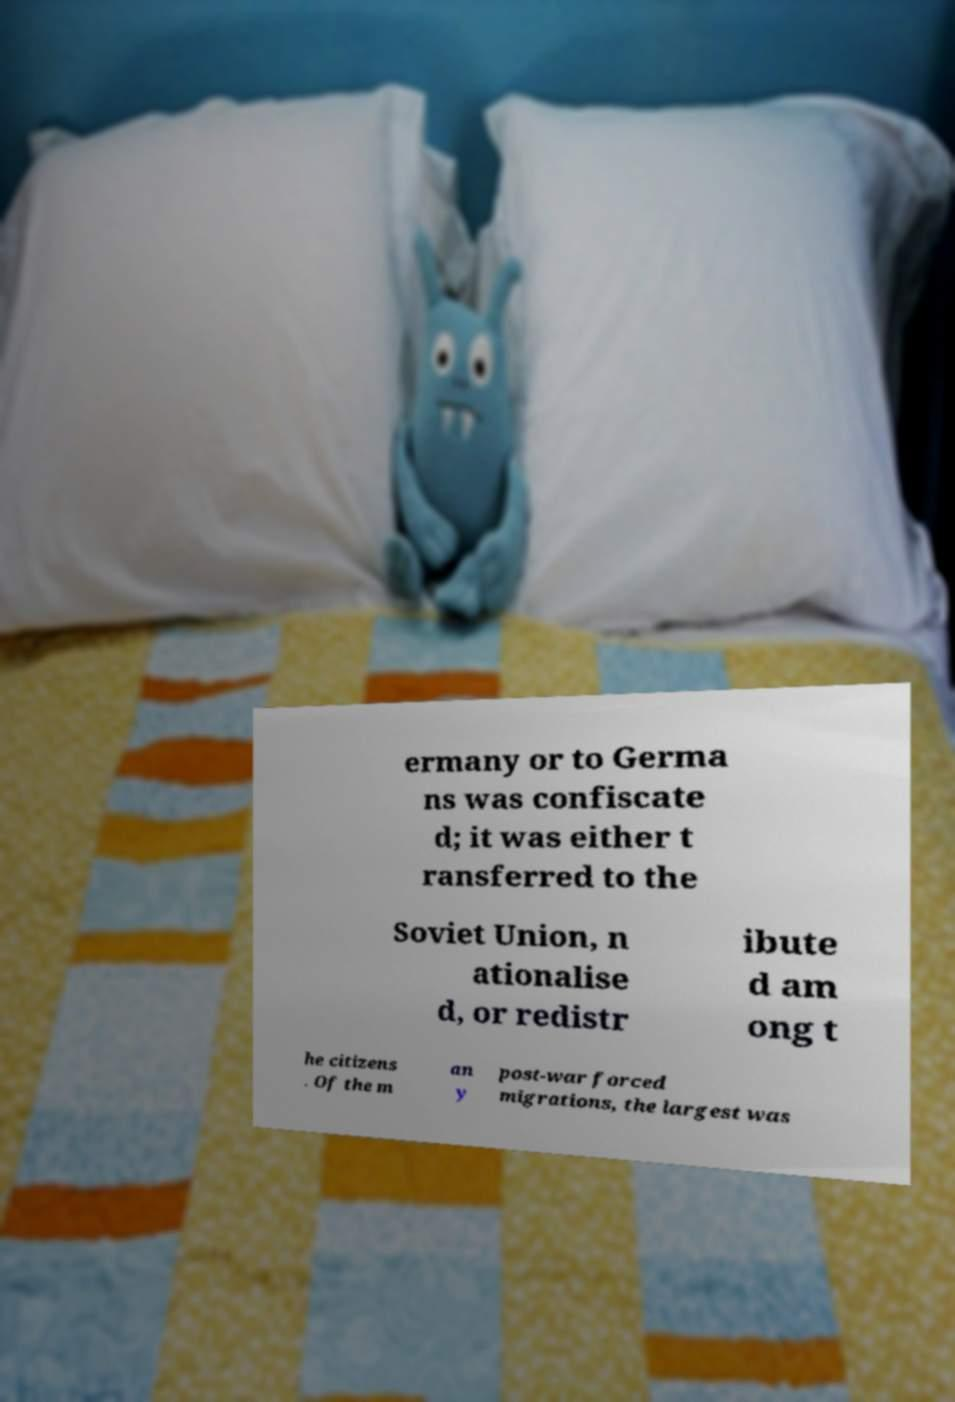Can you accurately transcribe the text from the provided image for me? ermany or to Germa ns was confiscate d; it was either t ransferred to the Soviet Union, n ationalise d, or redistr ibute d am ong t he citizens . Of the m an y post-war forced migrations, the largest was 